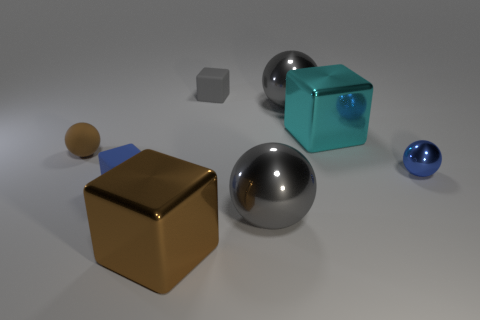What is the material of the big gray thing behind the large cyan cube?
Your response must be concise. Metal. What size is the brown shiny block to the right of the tiny ball behind the tiny metal ball on the right side of the brown rubber thing?
Your response must be concise. Large. Does the small ball on the right side of the cyan shiny thing have the same material as the gray sphere that is in front of the big cyan metallic object?
Make the answer very short. Yes. What number of other things are there of the same color as the tiny metallic sphere?
Keep it short and to the point. 1. How many things are large things to the right of the big brown thing or rubber things behind the small metal sphere?
Keep it short and to the point. 5. There is a rubber block that is behind the small blue thing that is to the right of the small gray rubber block; what is its size?
Your answer should be very brief. Small. How big is the cyan cube?
Offer a terse response. Large. Do the ball to the left of the tiny blue block and the rubber block that is behind the cyan cube have the same color?
Keep it short and to the point. No. What number of other things are made of the same material as the small gray object?
Your response must be concise. 2. Are any yellow rubber balls visible?
Provide a short and direct response. No. 